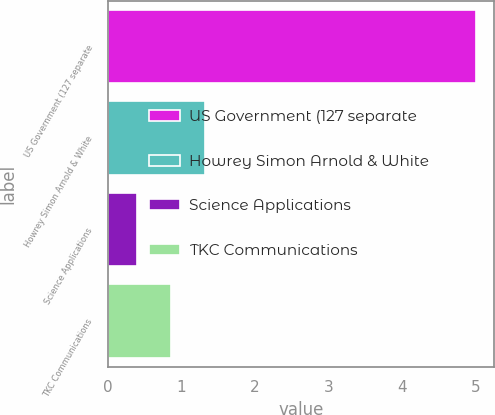Convert chart to OTSL. <chart><loc_0><loc_0><loc_500><loc_500><bar_chart><fcel>US Government (127 separate<fcel>Howrey Simon Arnold & White<fcel>Science Applications<fcel>TKC Communications<nl><fcel>5<fcel>1.32<fcel>0.4<fcel>0.86<nl></chart> 